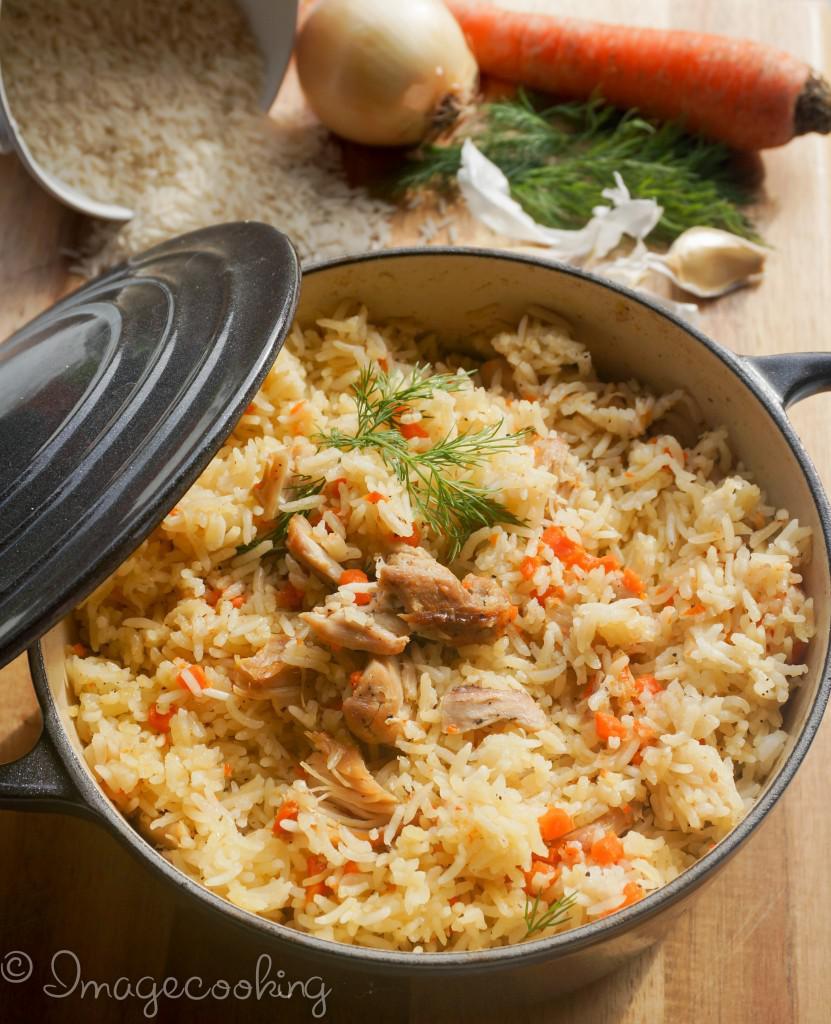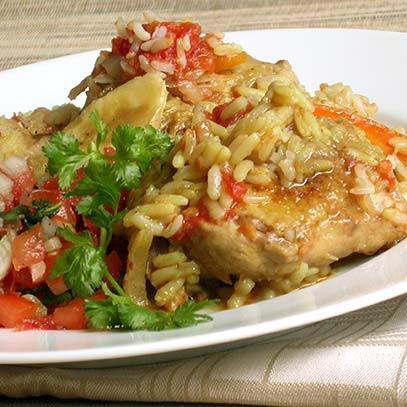The first image is the image on the left, the second image is the image on the right. Considering the images on both sides, is "One image shows a one-pot meal in a round container with two handles that is not sitting on a heat source." valid? Answer yes or no. No. The first image is the image on the left, the second image is the image on the right. Assess this claim about the two images: "Food is on a plate in one of the images.". Correct or not? Answer yes or no. Yes. 